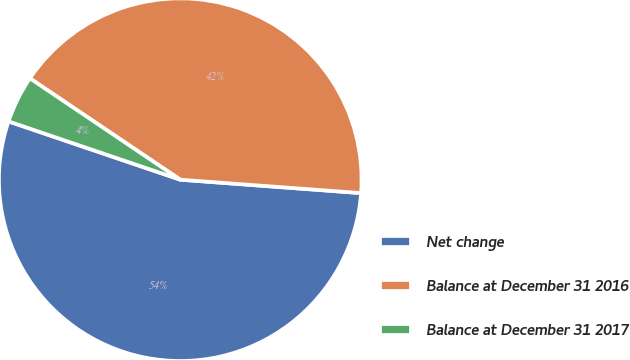Convert chart. <chart><loc_0><loc_0><loc_500><loc_500><pie_chart><fcel>Net change<fcel>Balance at December 31 2016<fcel>Balance at December 31 2017<nl><fcel>54.03%<fcel>41.74%<fcel>4.23%<nl></chart> 